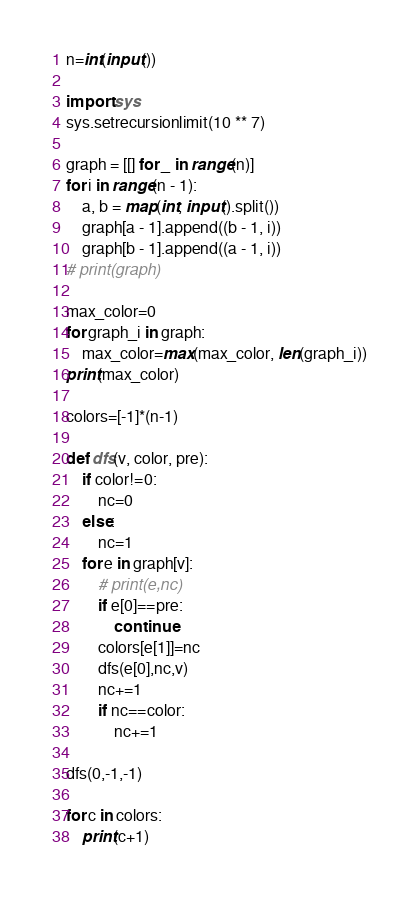Convert code to text. <code><loc_0><loc_0><loc_500><loc_500><_Python_>n=int(input())

import sys
sys.setrecursionlimit(10 ** 7)

graph = [[] for _ in range(n)]
for i in range(n - 1):
    a, b = map(int, input().split())
    graph[a - 1].append((b - 1, i))
    graph[b - 1].append((a - 1, i))
# print(graph)

max_color=0
for graph_i in graph:
    max_color=max(max_color, len(graph_i))
print(max_color)

colors=[-1]*(n-1)

def dfs(v, color, pre):
    if color!=0:
        nc=0
    else:
        nc=1
    for e in graph[v]:
        # print(e,nc)
        if e[0]==pre:
            continue
        colors[e[1]]=nc
        dfs(e[0],nc,v)
        nc+=1
        if nc==color:
            nc+=1

dfs(0,-1,-1)

for c in colors:
    print(c+1)
</code> 